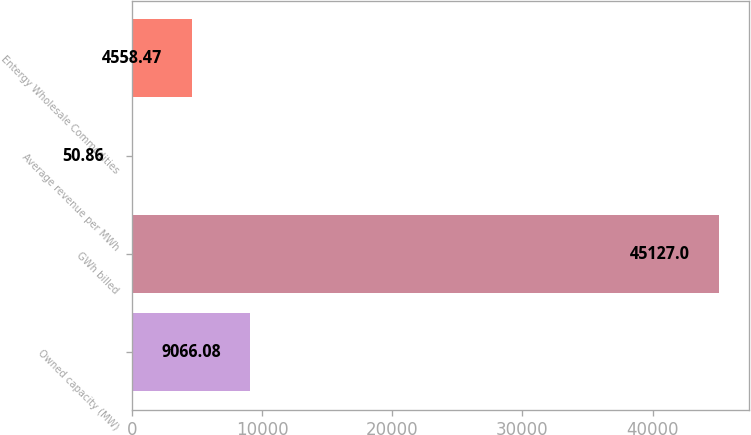Convert chart. <chart><loc_0><loc_0><loc_500><loc_500><bar_chart><fcel>Owned capacity (MW)<fcel>GWh billed<fcel>Average revenue per MWh<fcel>Entergy Wholesale Commodities<nl><fcel>9066.08<fcel>45127<fcel>50.86<fcel>4558.47<nl></chart> 